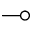Convert formula to latex. <formula><loc_0><loc_0><loc_500><loc_500>\mu l t i m a p</formula> 